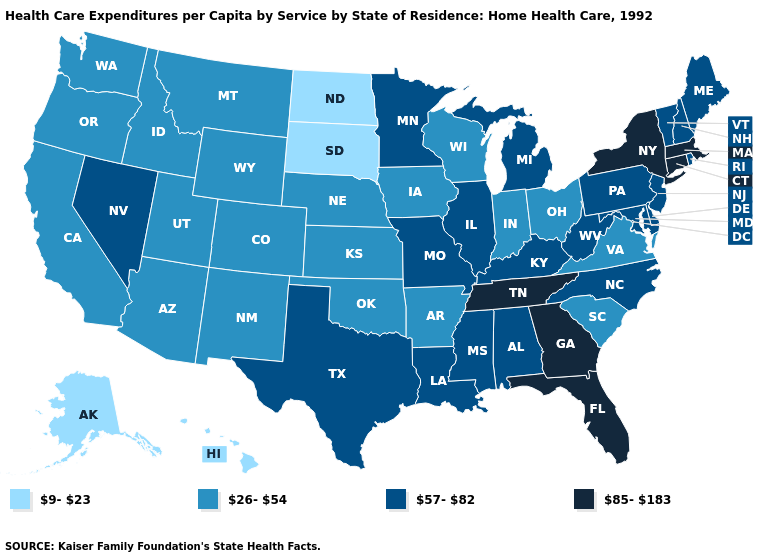What is the highest value in states that border Indiana?
Short answer required. 57-82. What is the highest value in the USA?
Keep it brief. 85-183. What is the value of Indiana?
Give a very brief answer. 26-54. What is the value of Alaska?
Concise answer only. 9-23. Name the states that have a value in the range 57-82?
Be succinct. Alabama, Delaware, Illinois, Kentucky, Louisiana, Maine, Maryland, Michigan, Minnesota, Mississippi, Missouri, Nevada, New Hampshire, New Jersey, North Carolina, Pennsylvania, Rhode Island, Texas, Vermont, West Virginia. What is the value of Illinois?
Keep it brief. 57-82. What is the lowest value in states that border Montana?
Give a very brief answer. 9-23. Name the states that have a value in the range 57-82?
Keep it brief. Alabama, Delaware, Illinois, Kentucky, Louisiana, Maine, Maryland, Michigan, Minnesota, Mississippi, Missouri, Nevada, New Hampshire, New Jersey, North Carolina, Pennsylvania, Rhode Island, Texas, Vermont, West Virginia. Among the states that border Rhode Island , which have the lowest value?
Write a very short answer. Connecticut, Massachusetts. Which states have the highest value in the USA?
Quick response, please. Connecticut, Florida, Georgia, Massachusetts, New York, Tennessee. Which states have the lowest value in the South?
Concise answer only. Arkansas, Oklahoma, South Carolina, Virginia. Is the legend a continuous bar?
Quick response, please. No. What is the value of New Jersey?
Be succinct. 57-82. What is the lowest value in the MidWest?
Short answer required. 9-23. What is the lowest value in the South?
Keep it brief. 26-54. 